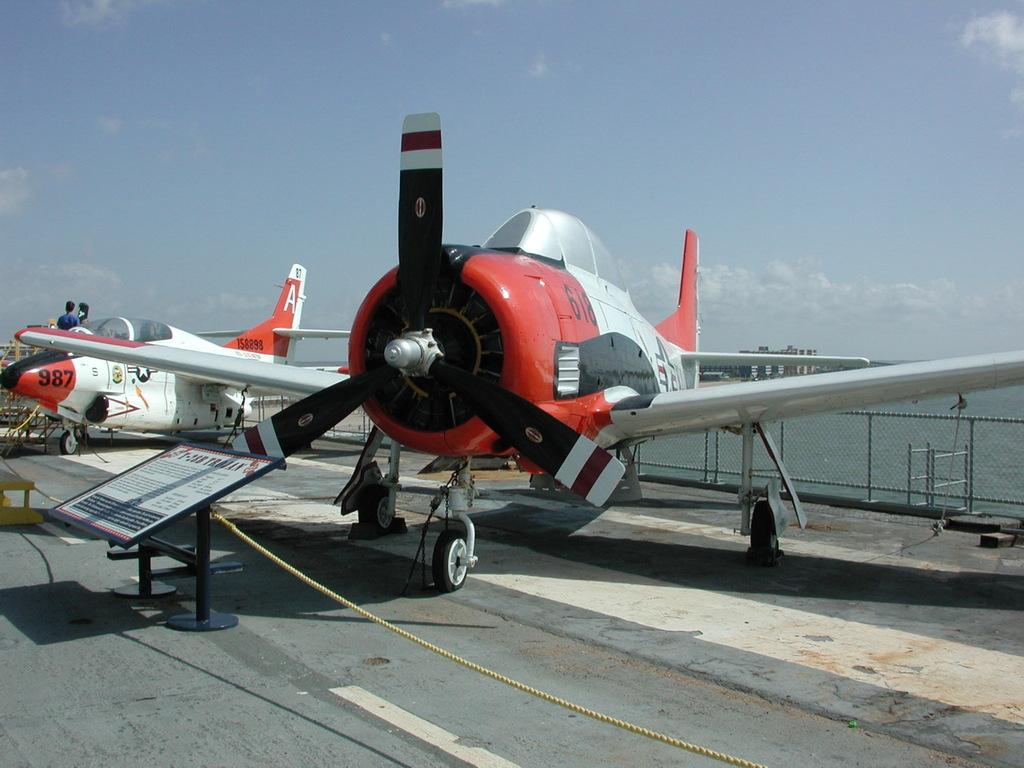<image>
Write a terse but informative summary of the picture. A red and silver propeller airplane called the T-28B Trojan 